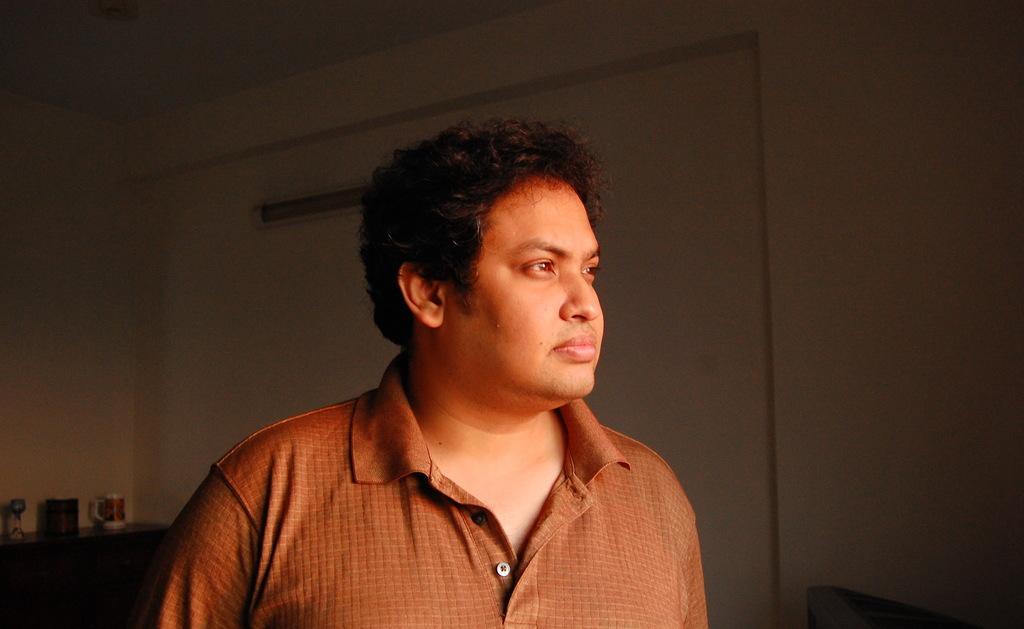How would you summarize this image in a sentence or two? There is a man wearing a brown shirt. On the left side there is a table. On the table there is a cup and some other things. In the back there's a wall. 